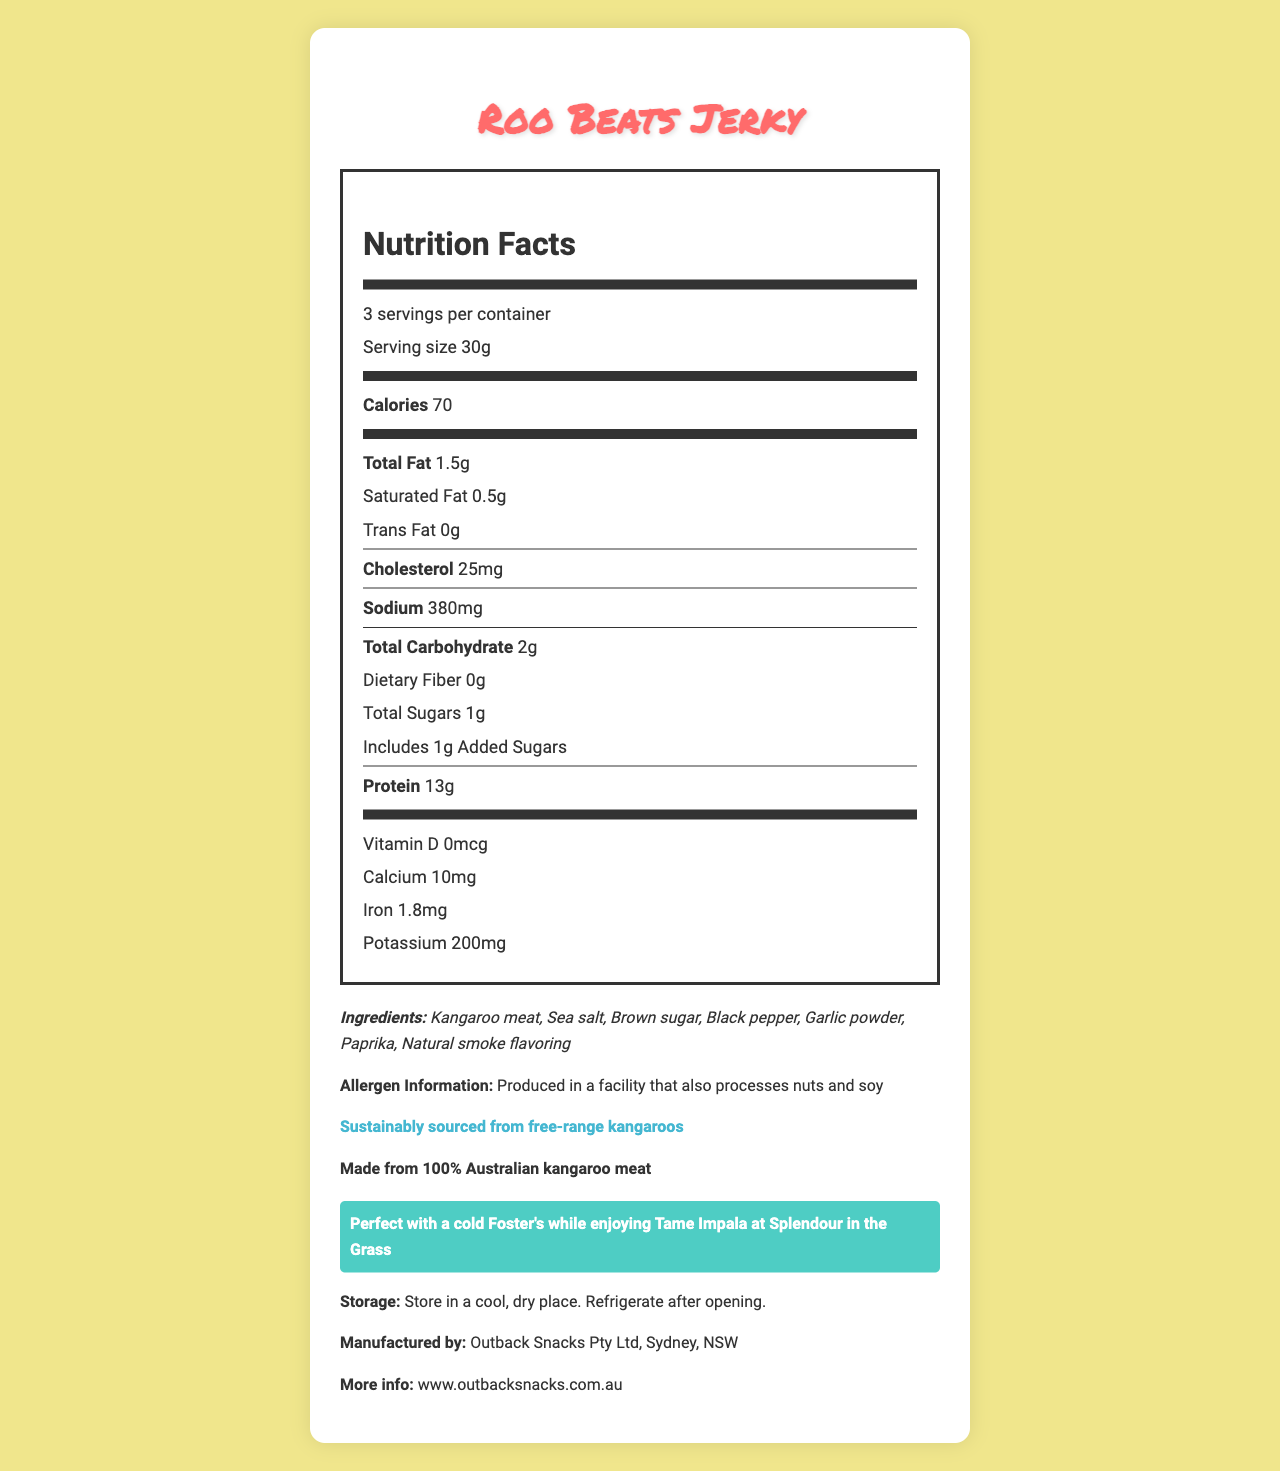What is the serving size of Roo Beats Jerky? The document states that the serving size is 30g at the beginning of the Nutrition Facts section.
Answer: 30g How many servings are there per container? The document mentions that there are 3 servings per container in the Nutrition Facts section.
Answer: 3 How many calories are in one serving of Roo Beats Jerky? The Nutrition Facts section states that each serving contains 70 calories.
Answer: 70 What is the total fat content per serving? The document shows that each serving has a total fat content of 1.5g.
Answer: 1.5g What are the ingredients of Roo Beats Jerky? The document lists these ingredients in the ingredients section.
Answer: Kangaroo meat, Sea salt, Brown sugar, Black pepper, Garlic powder, Paprika, Natural smoke flavoring What is the protein content per serving? A. 5g B. 10g C. 13g D. 15g The Nutrition Facts section indicates that there are 13g of protein per serving.
Answer: C What is the sodium content per serving of Roo Beats Jerky? A. 180mg B. 250mg C. 380mg D. 420mg The Nutrition Facts section shows that each serving has 380mg of sodium.
Answer: C Is Roo Beats Jerky made from Australian kangaroo meat? The document mentions "Made from 100% Australian kangaroo meat" and "Sustainably sourced from free-range kangaroos".
Answer: Yes Does Roo Beats Jerky contain any trans fat? The document states that the trans fat content per serving is 0g.
Answer: No Summarize the main themes of the Roo Beats Jerky Nutrition Facts Label. The document includes detailed nutritional information, ingredient list, allergen warnings, sustainability note, festival pairing suggestion, storage instructions, and manufacturer details.
Answer: Roo Beats Jerky is a high-protein kangaroo meat jerky snack featuring 70 calories per serving, minimal fat, no trans fats, and is made from sustainably sourced, 100% Australian kangaroo meat. It is perfect for music festivals and should be stored in a cool, dry place. What is the manufacturer's website? The document specifies the manufacturer's website at the end of the label.
Answer: www.outbacksnacks.com.au What is the cholesterol content per serving? The Nutrition Facts section indicates there are 25mg of cholesterol per serving.
Answer: 25mg Is Roo Beats Jerky suitable for someone with a nut allergy? The document states that it is produced in a facility that also processes nuts, posing a risk of cross-contamination for those with nut allergies.
Answer: Not necessarily What drink is Roo Beats Jerky paired with for a festival experience? The document mentions pairing Roo Beats Jerky with a cold Foster's while enjoying Tame Impala at Splendour in the Grass.
Answer: Foster's beer Does Roo Beats Jerky contain any dietary fiber? The Nutrition Facts section states there is 0g of dietary fiber per serving.
Answer: No Describe the sustainability note mentioned on the Roo Beats Jerky Nutrition Facts Label. The document includes a sustainability note that highlights the jerky is sourced from free-range kangaroos.
Answer: Sustainably sourced from free-range kangaroos How should Roo Beats Jerky be stored after opening? The document instructs to "Store in a cool, dry place. Refrigerate after opening."
Answer: Refrigerate after opening What is the percentage of daily value of vitamin D in Roo Beats Jerky? The document does not mention the percentage of daily value, only stating that vitamin D content is 0mcg.
Answer: Not enough information 